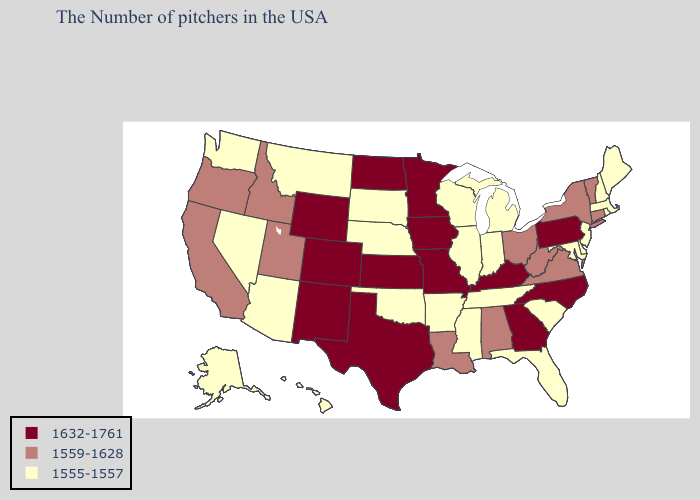What is the highest value in states that border Minnesota?
Short answer required. 1632-1761. What is the lowest value in the USA?
Keep it brief. 1555-1557. What is the value of Georgia?
Be succinct. 1632-1761. Does Virginia have a lower value than Rhode Island?
Keep it brief. No. What is the value of Montana?
Write a very short answer. 1555-1557. Name the states that have a value in the range 1632-1761?
Keep it brief. Pennsylvania, North Carolina, Georgia, Kentucky, Missouri, Minnesota, Iowa, Kansas, Texas, North Dakota, Wyoming, Colorado, New Mexico. Is the legend a continuous bar?
Short answer required. No. What is the value of Maryland?
Quick response, please. 1555-1557. Among the states that border Mississippi , does Alabama have the highest value?
Give a very brief answer. Yes. Does Arizona have the lowest value in the West?
Keep it brief. Yes. What is the value of Tennessee?
Be succinct. 1555-1557. How many symbols are there in the legend?
Write a very short answer. 3. Name the states that have a value in the range 1632-1761?
Short answer required. Pennsylvania, North Carolina, Georgia, Kentucky, Missouri, Minnesota, Iowa, Kansas, Texas, North Dakota, Wyoming, Colorado, New Mexico. 